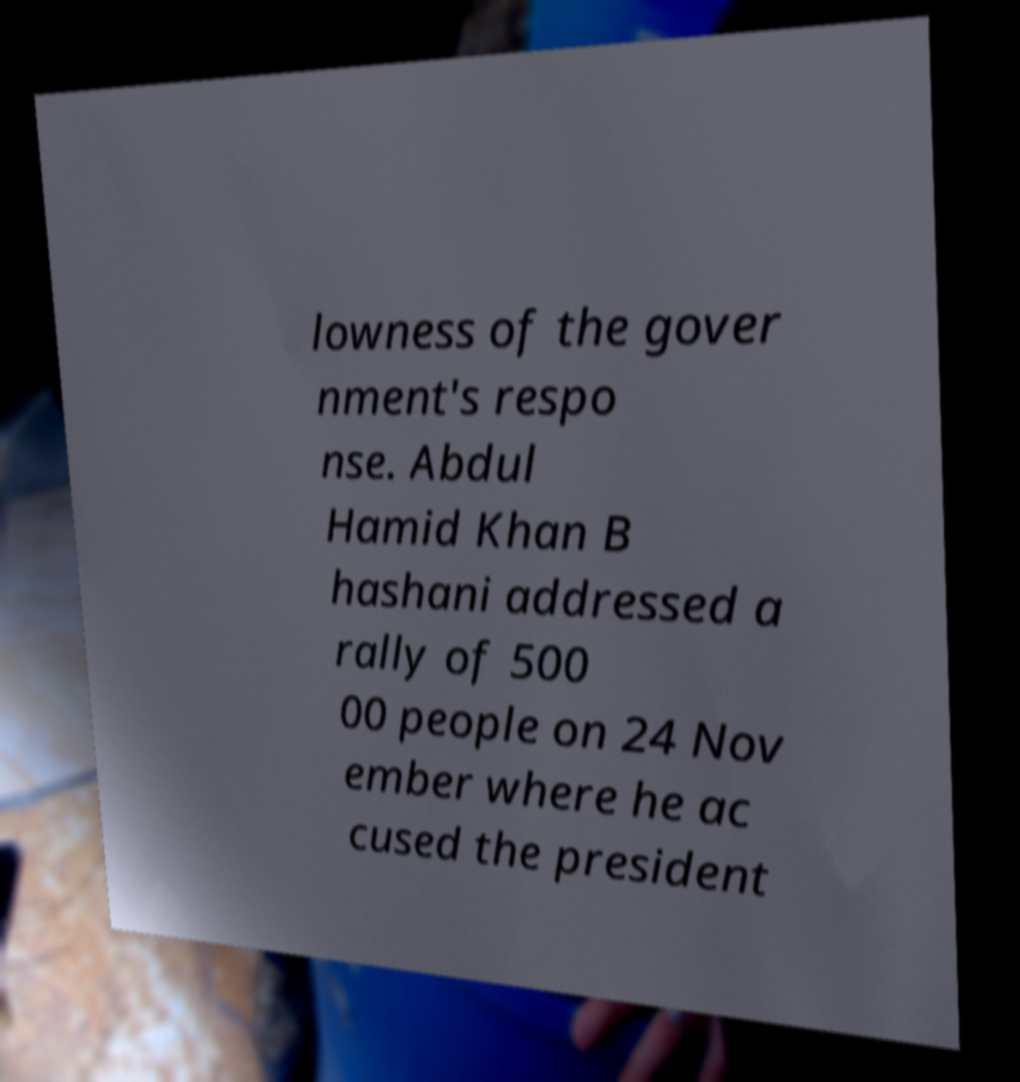What messages or text are displayed in this image? I need them in a readable, typed format. lowness of the gover nment's respo nse. Abdul Hamid Khan B hashani addressed a rally of 500 00 people on 24 Nov ember where he ac cused the president 